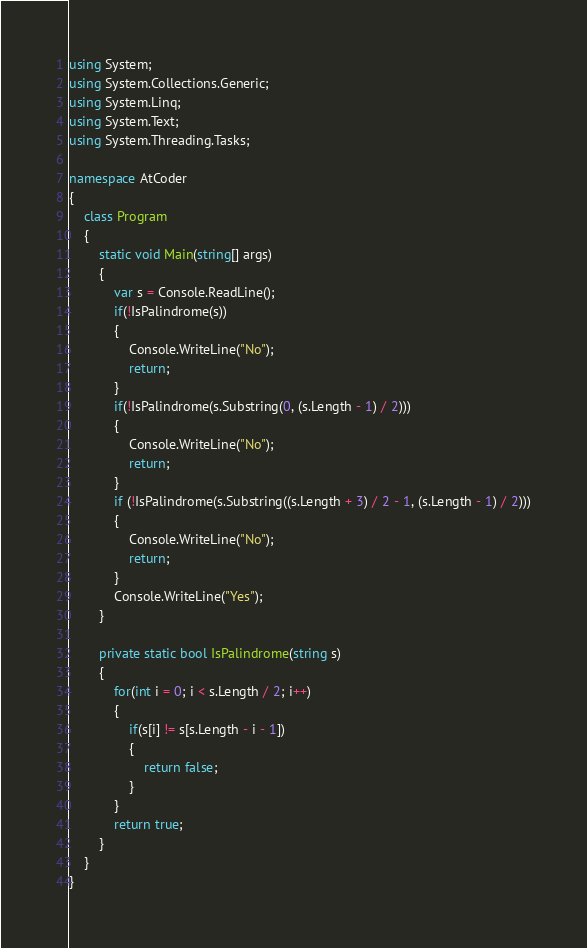<code> <loc_0><loc_0><loc_500><loc_500><_C#_>using System;
using System.Collections.Generic;
using System.Linq;
using System.Text;
using System.Threading.Tasks;

namespace AtCoder
{
	class Program
	{
		static void Main(string[] args)
		{
			var s = Console.ReadLine();
			if(!IsPalindrome(s))
			{
				Console.WriteLine("No");
				return;
			}
			if(!IsPalindrome(s.Substring(0, (s.Length - 1) / 2)))
			{
				Console.WriteLine("No");
				return;
			}
			if (!IsPalindrome(s.Substring((s.Length + 3) / 2 - 1, (s.Length - 1) / 2)))
			{
				Console.WriteLine("No");
				return;
			}
			Console.WriteLine("Yes");
		}

		private static bool IsPalindrome(string s)
		{
			for(int i = 0; i < s.Length / 2; i++)
			{
				if(s[i] != s[s.Length - i - 1])
				{
					return false;
				}
			}
			return true;
		}
	}
}
</code> 